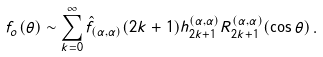<formula> <loc_0><loc_0><loc_500><loc_500>f _ { o } ( \theta ) \sim \sum _ { k = 0 } ^ { \infty } { \hat { f } } _ { ( \alpha , \alpha ) } ( 2 k + 1 ) h _ { 2 k + 1 } ^ { ( \alpha , \alpha ) } R _ { 2 k + 1 } ^ { ( \alpha , \alpha ) } ( \cos \theta ) \, .</formula> 